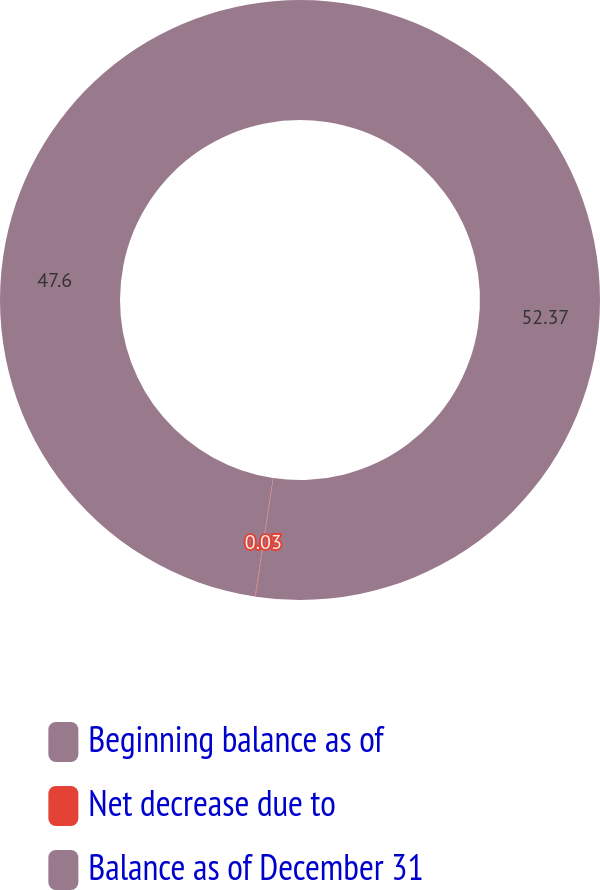<chart> <loc_0><loc_0><loc_500><loc_500><pie_chart><fcel>Beginning balance as of<fcel>Net decrease due to<fcel>Balance as of December 31<nl><fcel>52.36%<fcel>0.03%<fcel>47.6%<nl></chart> 